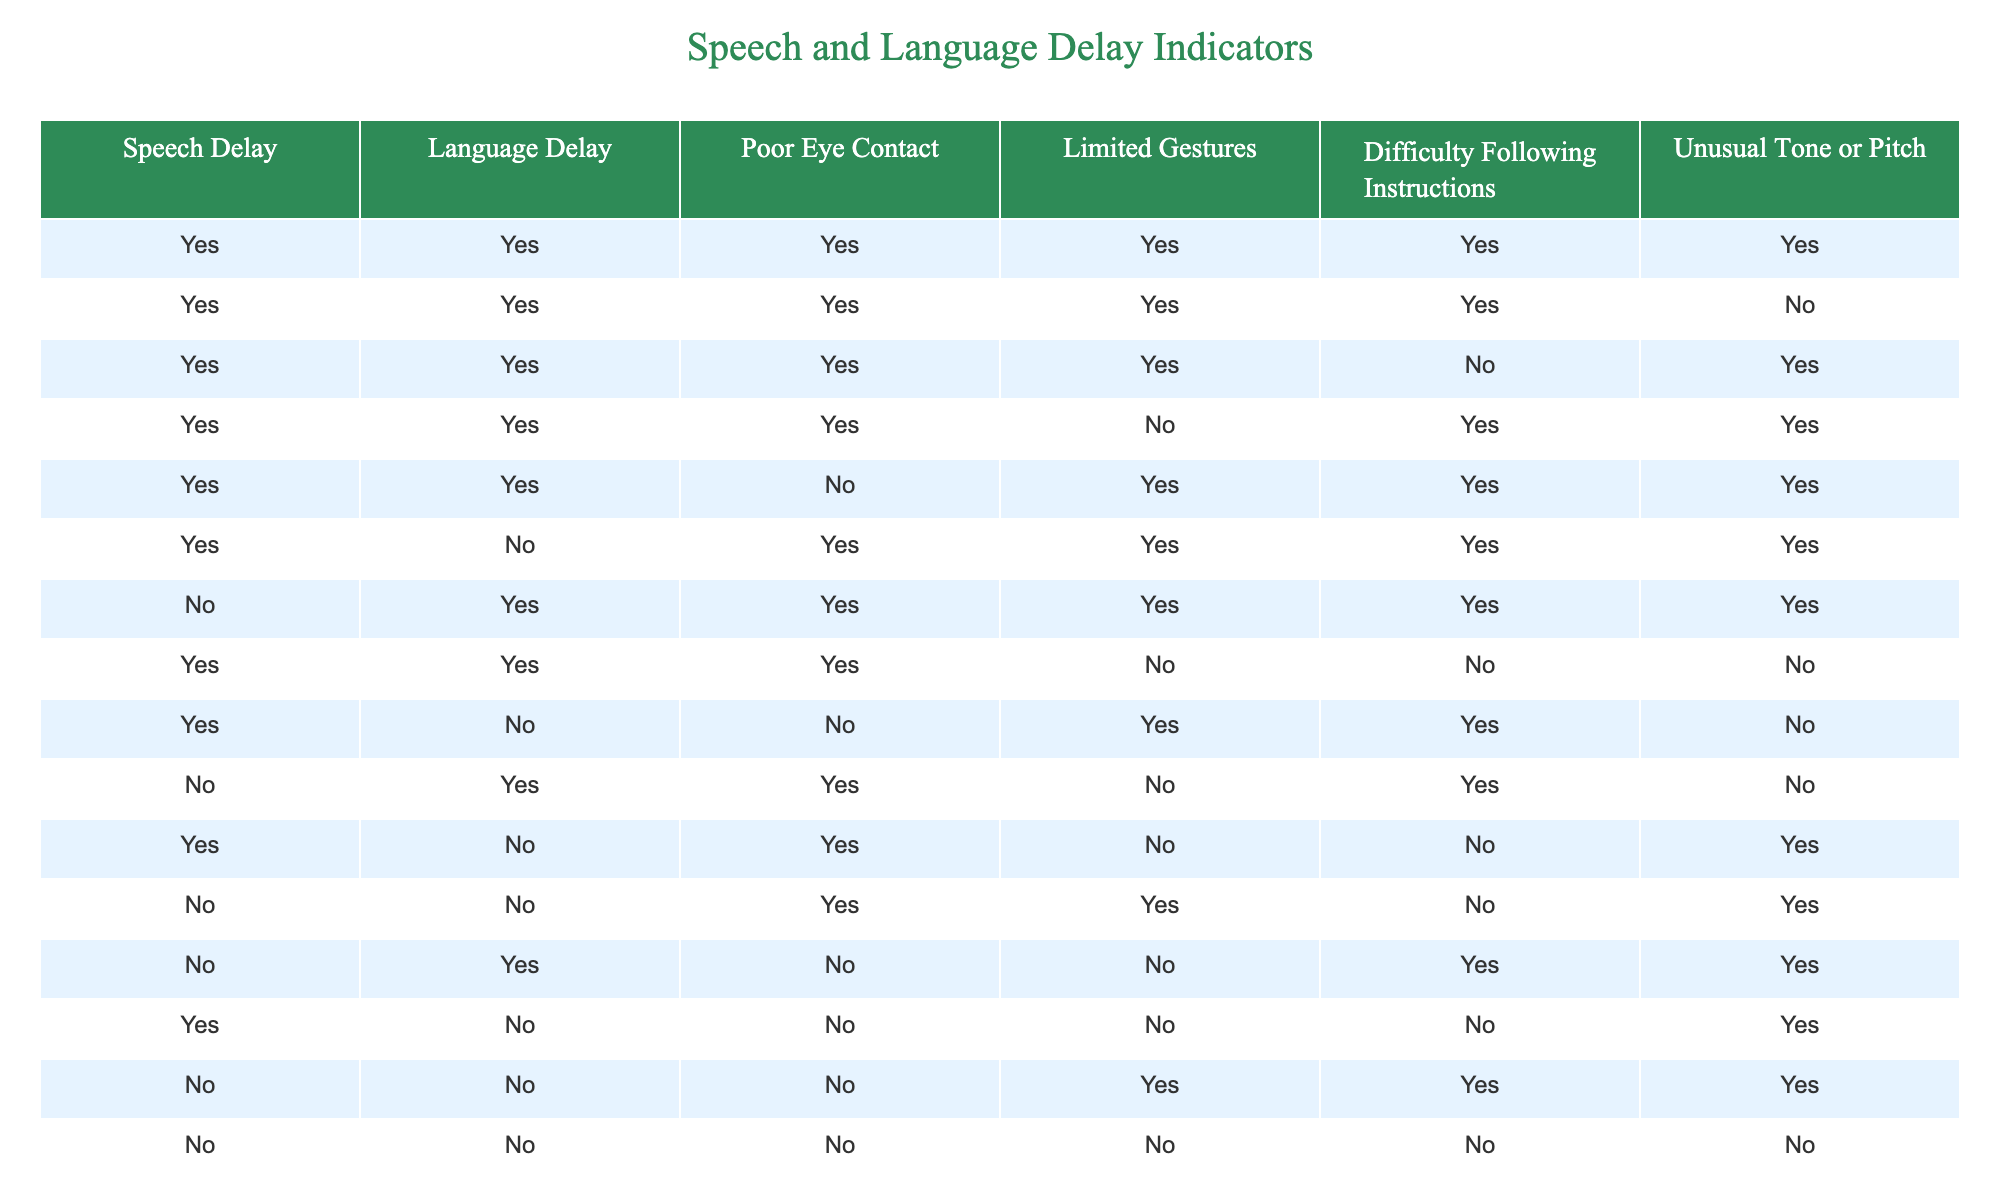What percentage of cases indicate both speech delay and language delay? There are 14 total cases in the table. Counting the rows where both Speech Delay and Language Delay are true (1 of 2 indicators), we find 7 instances. To calculate the percentage, we use (7/14) * 100 = 50%.
Answer: 50% How many cases show Poor Eye Contact but not Language Delay? Looking at the table, we need to identify the rows where Poor Eye Contact is true (Yes) and Language Delay is false (No). Scanning through the table, we find 2 such cases (the 11th and 14th rows).
Answer: 2 Is there any case where there is a speech delay but not a language delay? We review the table for instances where Speech Delay is true (Yes) while Language Delay is false (No). Observing the table, the 6th, 9th, and 12th rows conform to this condition, confirming the presence of such cases.
Answer: Yes What is the number of cases with Limited Gestures and Difficulty Following Instructions? To find this, we count the rows where both Limited Gestures and Difficulty Following Instructions are true (Yes). Upon counting the rows with both as Yes, we find there are a total of 5 cases meeting this requirement.
Answer: 5 If a child is showing Difficulty Following Instructions, how many cases also show Unusual Tone or Pitch? We begin by identifying the cases where Difficulty Following Instructions is true (Yes) and then filter those by whether Unusual Tone or Pitch is also true (Yes). Upon reviewing the table, we find that out of the total cases displaying Difficulty Following Instructions, 6 of them also show Unusual Tone or Pitch.
Answer: 6 How many different combinations of true indicators are there? To find the combinations, we check each row and note the unique combinations of truth values. There are 15 unique sets of true/false indicators present across the data points, confirming the various combinations present.
Answer: 15 